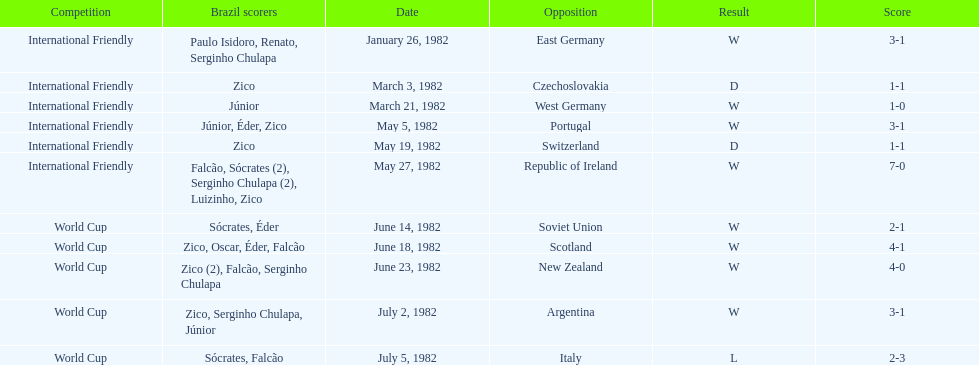How many times did brazil play west germany during the 1982 season? 1. 